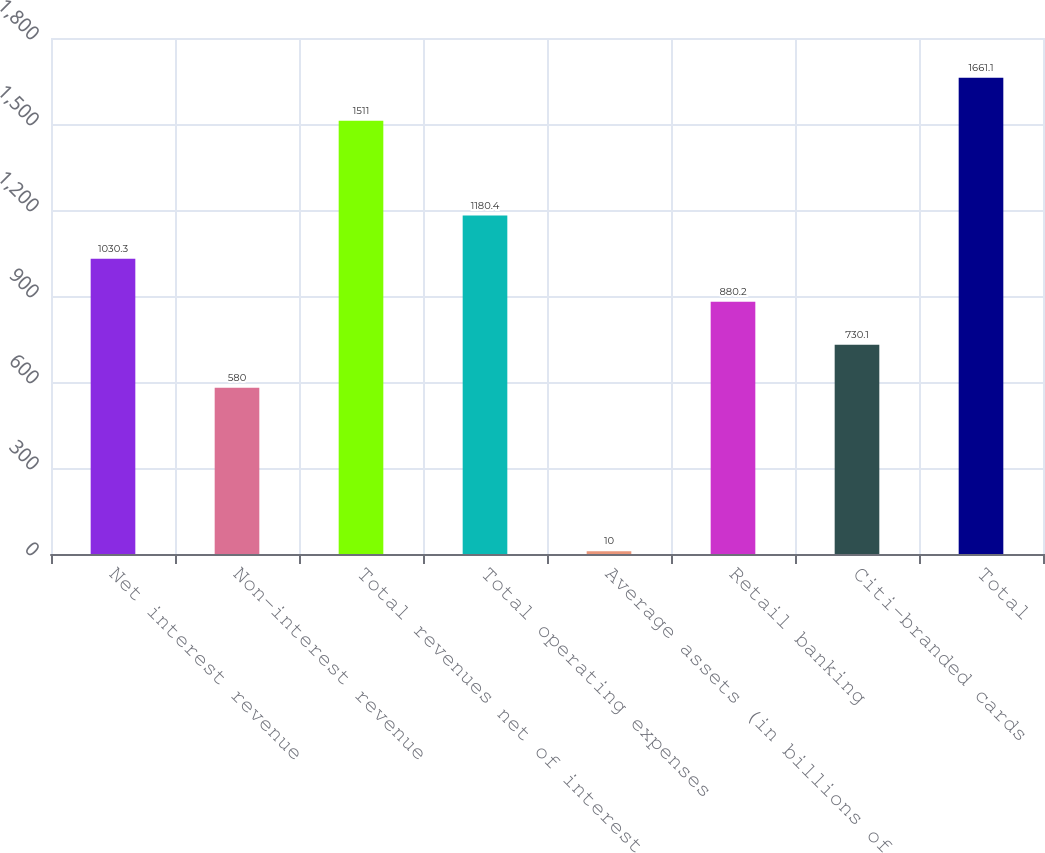Convert chart to OTSL. <chart><loc_0><loc_0><loc_500><loc_500><bar_chart><fcel>Net interest revenue<fcel>Non-interest revenue<fcel>Total revenues net of interest<fcel>Total operating expenses<fcel>Average assets (in billions of<fcel>Retail banking<fcel>Citi-branded cards<fcel>Total<nl><fcel>1030.3<fcel>580<fcel>1511<fcel>1180.4<fcel>10<fcel>880.2<fcel>730.1<fcel>1661.1<nl></chart> 